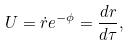Convert formula to latex. <formula><loc_0><loc_0><loc_500><loc_500>U = \dot { r } e ^ { - \phi } = \frac { d r } { d \tau } ,</formula> 